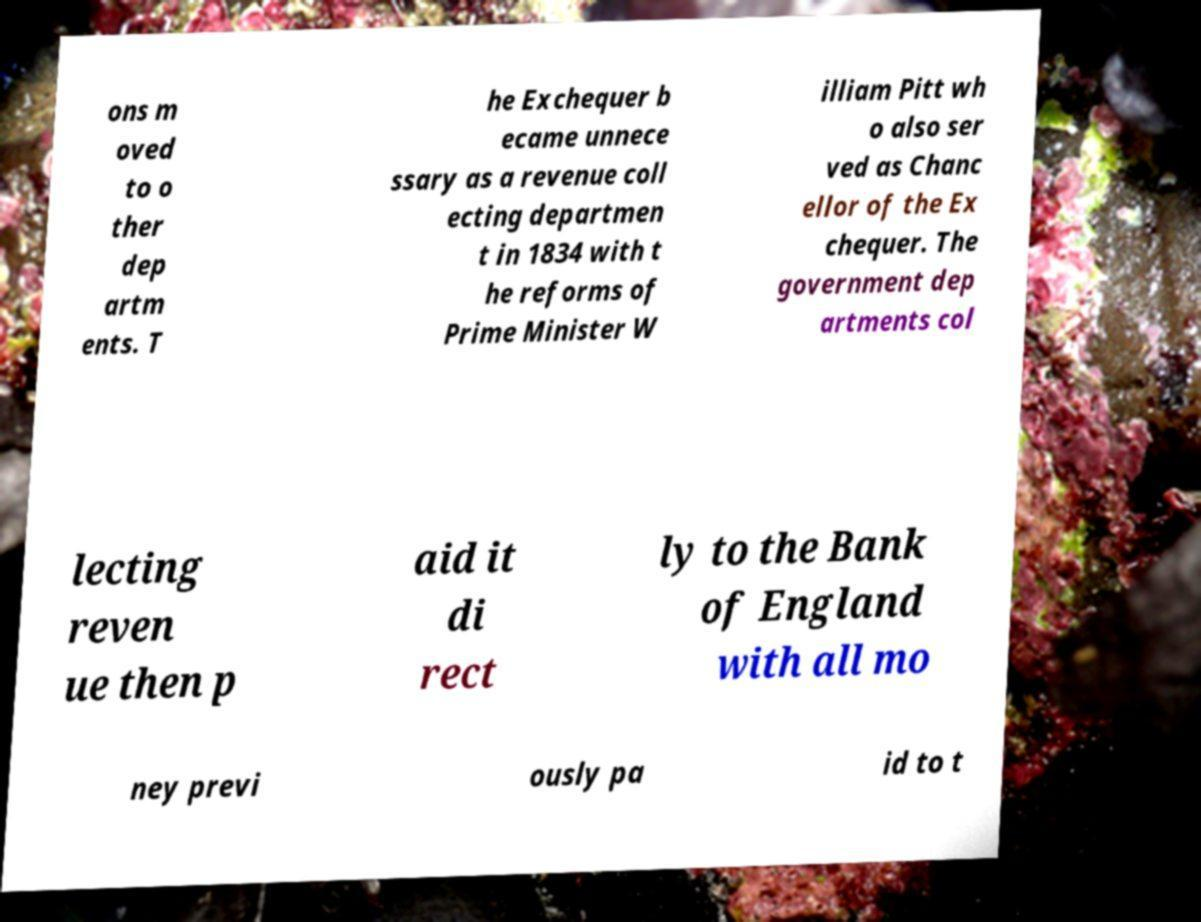I need the written content from this picture converted into text. Can you do that? ons m oved to o ther dep artm ents. T he Exchequer b ecame unnece ssary as a revenue coll ecting departmen t in 1834 with t he reforms of Prime Minister W illiam Pitt wh o also ser ved as Chanc ellor of the Ex chequer. The government dep artments col lecting reven ue then p aid it di rect ly to the Bank of England with all mo ney previ ously pa id to t 